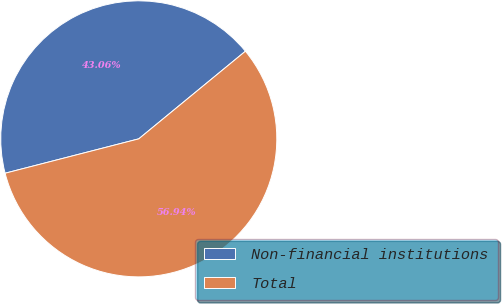<chart> <loc_0><loc_0><loc_500><loc_500><pie_chart><fcel>Non-financial institutions<fcel>Total<nl><fcel>43.06%<fcel>56.94%<nl></chart> 